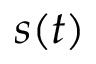<formula> <loc_0><loc_0><loc_500><loc_500>s ( t )</formula> 